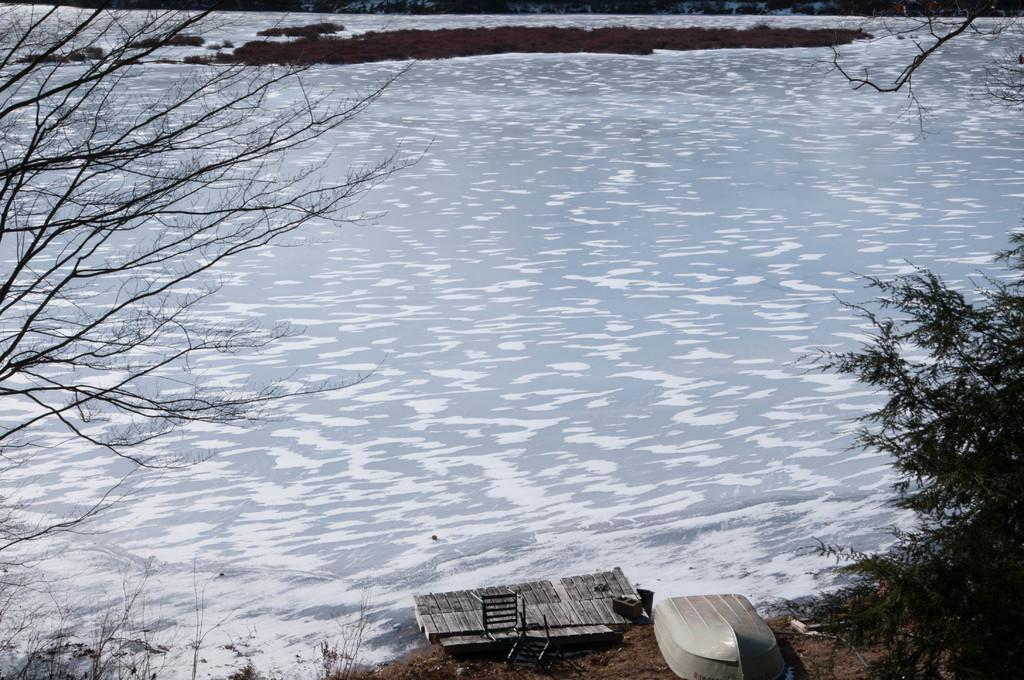What object is located in the foreground of the image? There is a chair in the foreground of the image. Where is the chair situated in relation to other elements in the image? The chair is near a dock. What can be seen on the ground in the foreground of the image? There is a boat on the ground in the foreground. What type of vegetation is present on either side of the image? Trees are present on either side of the image. What is visible in the background of the image? There is a rock and water visible in the background of the image. What type of fish can be seen swimming near the rock in the image? There are no fish visible in the image; only a rock and water are present in the background. What type of creature is sitting on the chair in the image? There is no creature sitting on the chair in the image; the chair is empty. 